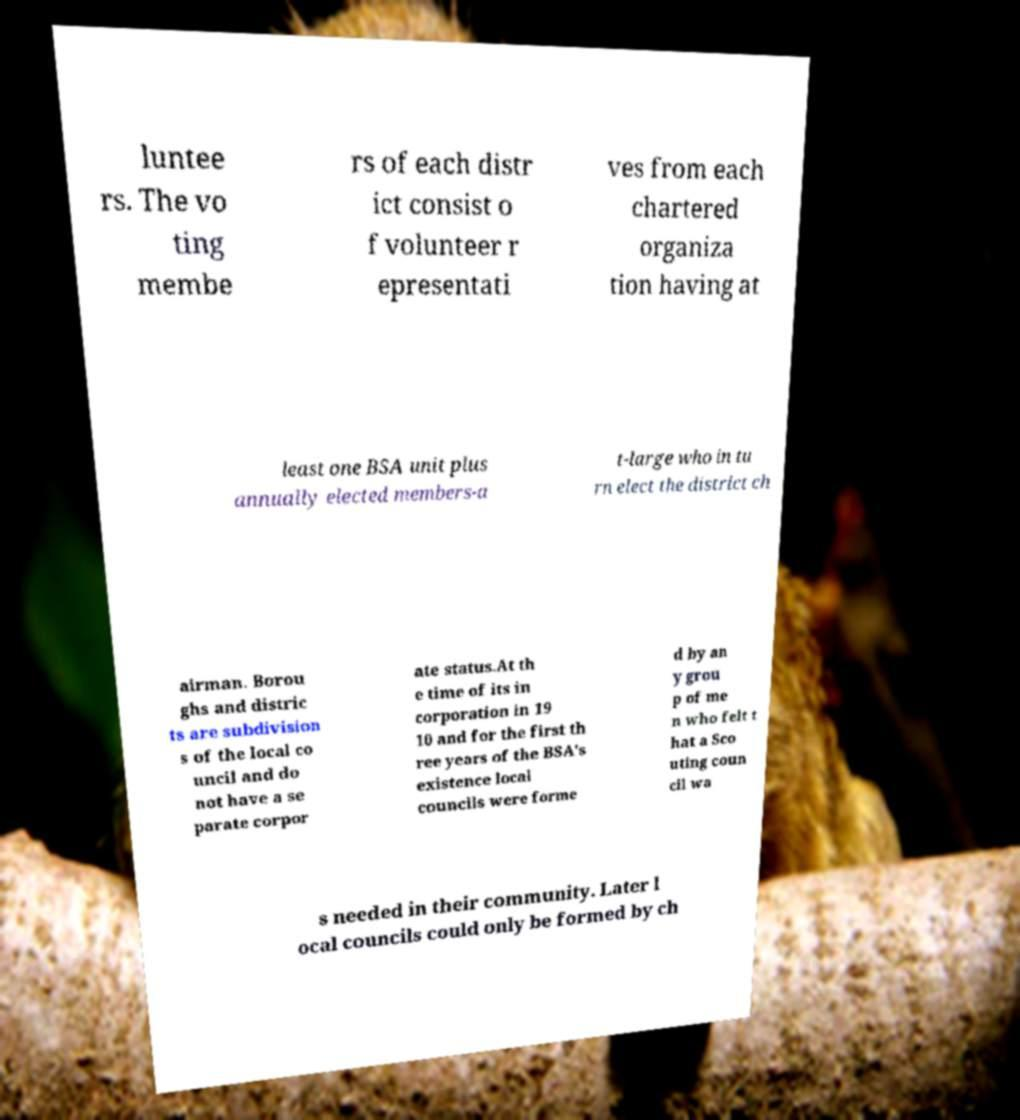Could you extract and type out the text from this image? luntee rs. The vo ting membe rs of each distr ict consist o f volunteer r epresentati ves from each chartered organiza tion having at least one BSA unit plus annually elected members-a t-large who in tu rn elect the district ch airman. Borou ghs and distric ts are subdivision s of the local co uncil and do not have a se parate corpor ate status.At th e time of its in corporation in 19 10 and for the first th ree years of the BSA's existence local councils were forme d by an y grou p of me n who felt t hat a Sco uting coun cil wa s needed in their community. Later l ocal councils could only be formed by ch 